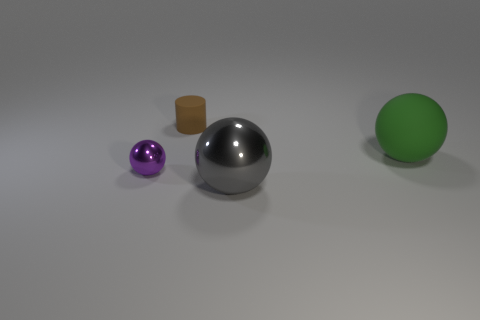Can you describe the shadows cast by the objects? Sure, the objects cast slight, soft-edged shadows towards the left side of the image. The intensity and softness of the shadows indicate a light source that's not overly harsh, possibly diffused through a medium, creating a gentle gradient rather than sharp, defined lines. Does the direction of the shadows help us determine the location of the light source? Yes, the direction of the shadows suggests that the light source is to the right of the objects, and slightly elevated given the angle at which the shadows stretch out. 